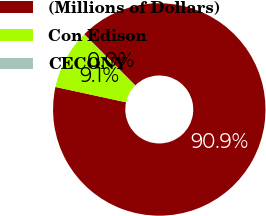<chart> <loc_0><loc_0><loc_500><loc_500><pie_chart><fcel>(Millions of Dollars)<fcel>Con Edison<fcel>CECONY<nl><fcel>90.88%<fcel>9.1%<fcel>0.02%<nl></chart> 